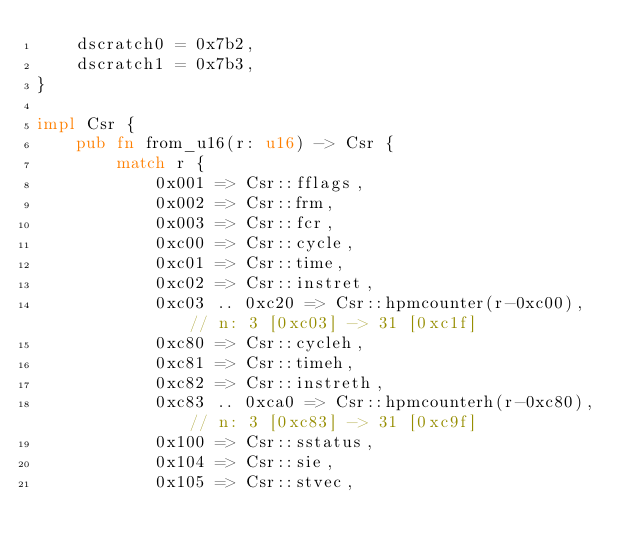Convert code to text. <code><loc_0><loc_0><loc_500><loc_500><_Rust_>    dscratch0 = 0x7b2,
    dscratch1 = 0x7b3,
}

impl Csr {
    pub fn from_u16(r: u16) -> Csr {
        match r {
            0x001 => Csr::fflags,
            0x002 => Csr::frm,
            0x003 => Csr::fcr,
            0xc00 => Csr::cycle,
            0xc01 => Csr::time,
            0xc02 => Csr::instret,
            0xc03 .. 0xc20 => Csr::hpmcounter(r-0xc00), // n: 3 [0xc03] -> 31 [0xc1f]
            0xc80 => Csr::cycleh,
            0xc81 => Csr::timeh,
            0xc82 => Csr::instreth,
            0xc83 .. 0xca0 => Csr::hpmcounterh(r-0xc80), // n: 3 [0xc83] -> 31 [0xc9f]
            0x100 => Csr::sstatus,
            0x104 => Csr::sie,
            0x105 => Csr::stvec,</code> 